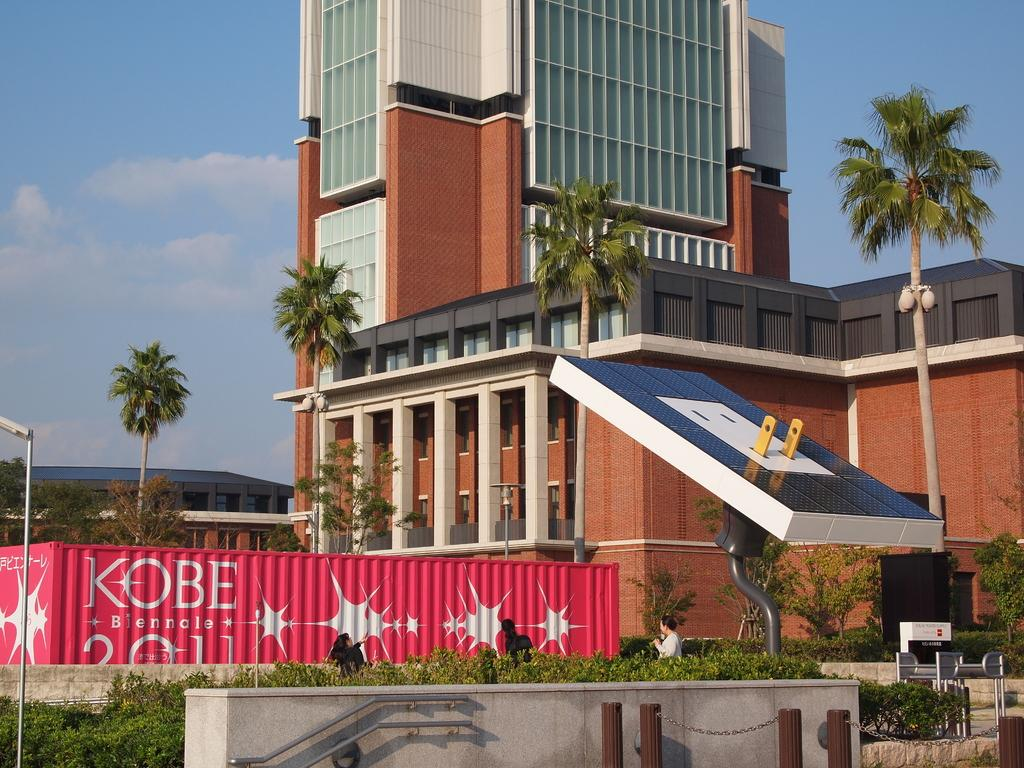What type of structures can be seen in the background of the image? There are buildings in the background of the image. What is located in front of the buildings? There are trees in front of the buildings. What can be found on the right side of the image? There is a statue on the right side of the image. What part of the natural environment is visible in the image? The sky is visible in the image. What is the condition of the sky in the image? Clouds are present in the sky. Can you tell me who won the argument between the buildings in the image? There is no argument present in the image; it features buildings, trees, a statue, and a sky with clouds. What type of drink is being served by the statue in the image? There is no drink or statue serving a drink in the image; it only features a statue on the right side. 